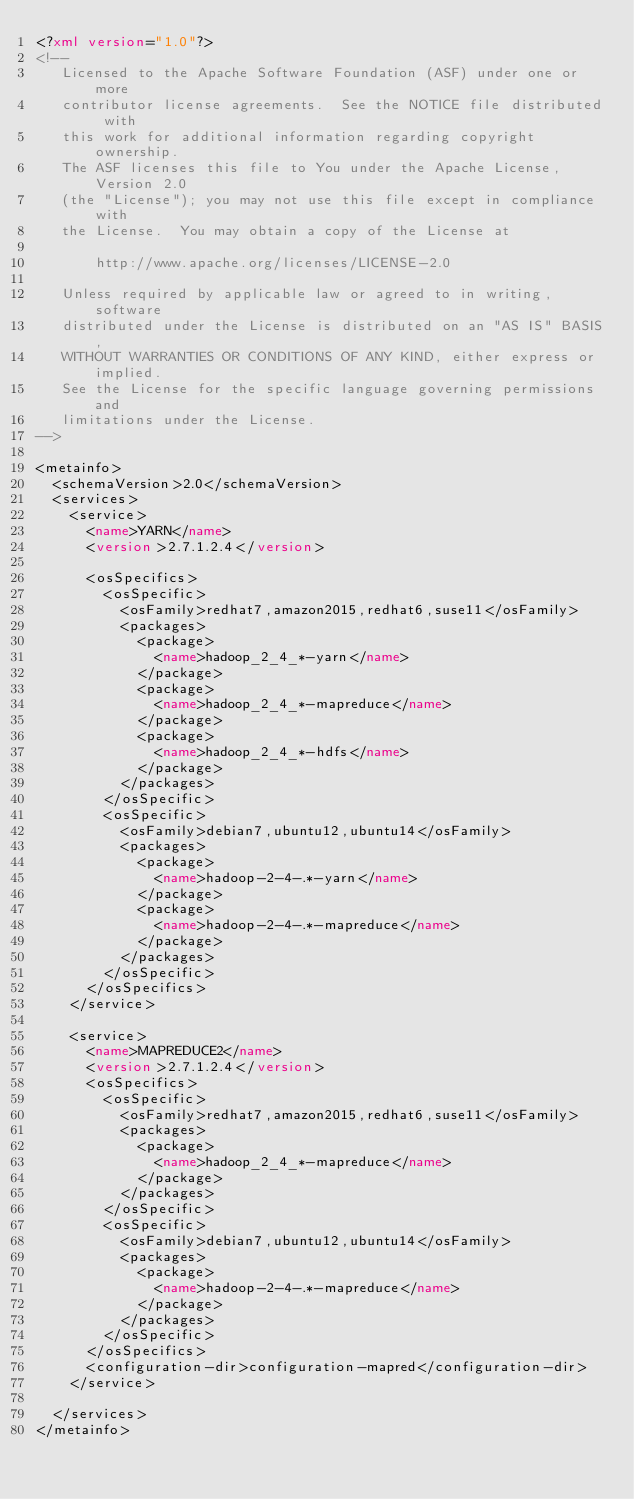<code> <loc_0><loc_0><loc_500><loc_500><_XML_><?xml version="1.0"?>
<!--
   Licensed to the Apache Software Foundation (ASF) under one or more
   contributor license agreements.  See the NOTICE file distributed with
   this work for additional information regarding copyright ownership.
   The ASF licenses this file to You under the Apache License, Version 2.0
   (the "License"); you may not use this file except in compliance with
   the License.  You may obtain a copy of the License at

       http://www.apache.org/licenses/LICENSE-2.0

   Unless required by applicable law or agreed to in writing, software
   distributed under the License is distributed on an "AS IS" BASIS,
   WITHOUT WARRANTIES OR CONDITIONS OF ANY KIND, either express or implied.
   See the License for the specific language governing permissions and
   limitations under the License.
-->

<metainfo>
  <schemaVersion>2.0</schemaVersion>
  <services>
    <service>
      <name>YARN</name>
      <version>2.7.1.2.4</version>

      <osSpecifics>
        <osSpecific>
          <osFamily>redhat7,amazon2015,redhat6,suse11</osFamily>
          <packages>
            <package>
              <name>hadoop_2_4_*-yarn</name>
            </package>
            <package>
              <name>hadoop_2_4_*-mapreduce</name>
            </package>
            <package>
              <name>hadoop_2_4_*-hdfs</name>
            </package>
          </packages>
        </osSpecific>
        <osSpecific>
          <osFamily>debian7,ubuntu12,ubuntu14</osFamily>
          <packages>
            <package>
              <name>hadoop-2-4-.*-yarn</name>
            </package>
            <package>
              <name>hadoop-2-4-.*-mapreduce</name>
            </package>
          </packages>
        </osSpecific>
      </osSpecifics>
    </service>

    <service>
      <name>MAPREDUCE2</name>
      <version>2.7.1.2.4</version>
      <osSpecifics>
        <osSpecific>
          <osFamily>redhat7,amazon2015,redhat6,suse11</osFamily>
          <packages>
            <package>
              <name>hadoop_2_4_*-mapreduce</name>
            </package>
          </packages>
        </osSpecific>
        <osSpecific>
          <osFamily>debian7,ubuntu12,ubuntu14</osFamily>
          <packages>
            <package>
              <name>hadoop-2-4-.*-mapreduce</name>
            </package>
          </packages>
        </osSpecific>
      </osSpecifics>
      <configuration-dir>configuration-mapred</configuration-dir>
    </service>

  </services>
</metainfo>
</code> 